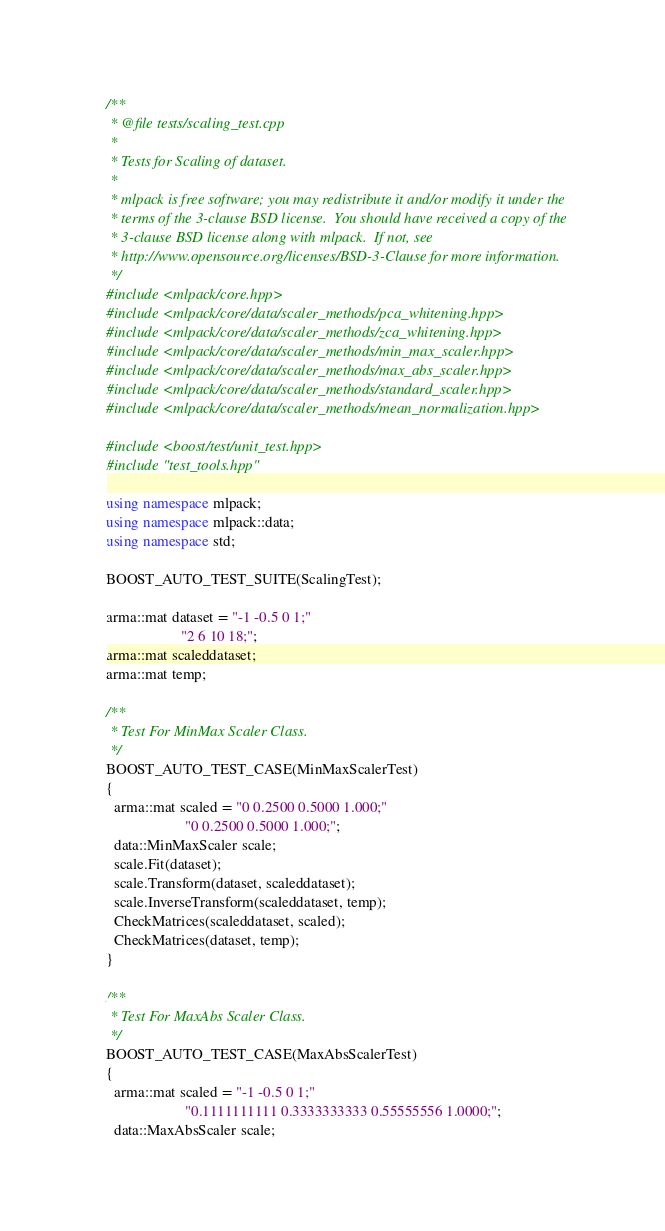<code> <loc_0><loc_0><loc_500><loc_500><_C++_>/**
 * @file tests/scaling_test.cpp
 *
 * Tests for Scaling of dataset.
 *
 * mlpack is free software; you may redistribute it and/or modify it under the
 * terms of the 3-clause BSD license.  You should have received a copy of the
 * 3-clause BSD license along with mlpack.  If not, see
 * http://www.opensource.org/licenses/BSD-3-Clause for more information.
 */
#include <mlpack/core.hpp>
#include <mlpack/core/data/scaler_methods/pca_whitening.hpp>
#include <mlpack/core/data/scaler_methods/zca_whitening.hpp>
#include <mlpack/core/data/scaler_methods/min_max_scaler.hpp>
#include <mlpack/core/data/scaler_methods/max_abs_scaler.hpp>
#include <mlpack/core/data/scaler_methods/standard_scaler.hpp>
#include <mlpack/core/data/scaler_methods/mean_normalization.hpp>

#include <boost/test/unit_test.hpp>
#include "test_tools.hpp"

using namespace mlpack;
using namespace mlpack::data;
using namespace std;

BOOST_AUTO_TEST_SUITE(ScalingTest);

arma::mat dataset = "-1 -0.5 0 1;"
                    "2 6 10 18;";
arma::mat scaleddataset;
arma::mat temp;

/**
 * Test For MinMax Scaler Class.
 */
BOOST_AUTO_TEST_CASE(MinMaxScalerTest)
{
  arma::mat scaled = "0 0.2500 0.5000 1.000;"
                     "0 0.2500 0.5000 1.000;";
  data::MinMaxScaler scale;
  scale.Fit(dataset);
  scale.Transform(dataset, scaleddataset);
  scale.InverseTransform(scaleddataset, temp);
  CheckMatrices(scaleddataset, scaled);
  CheckMatrices(dataset, temp);
}

/**
 * Test For MaxAbs Scaler Class.
 */
BOOST_AUTO_TEST_CASE(MaxAbsScalerTest)
{
  arma::mat scaled = "-1 -0.5 0 1;"
                     "0.1111111111 0.3333333333 0.55555556 1.0000;";
  data::MaxAbsScaler scale;</code> 